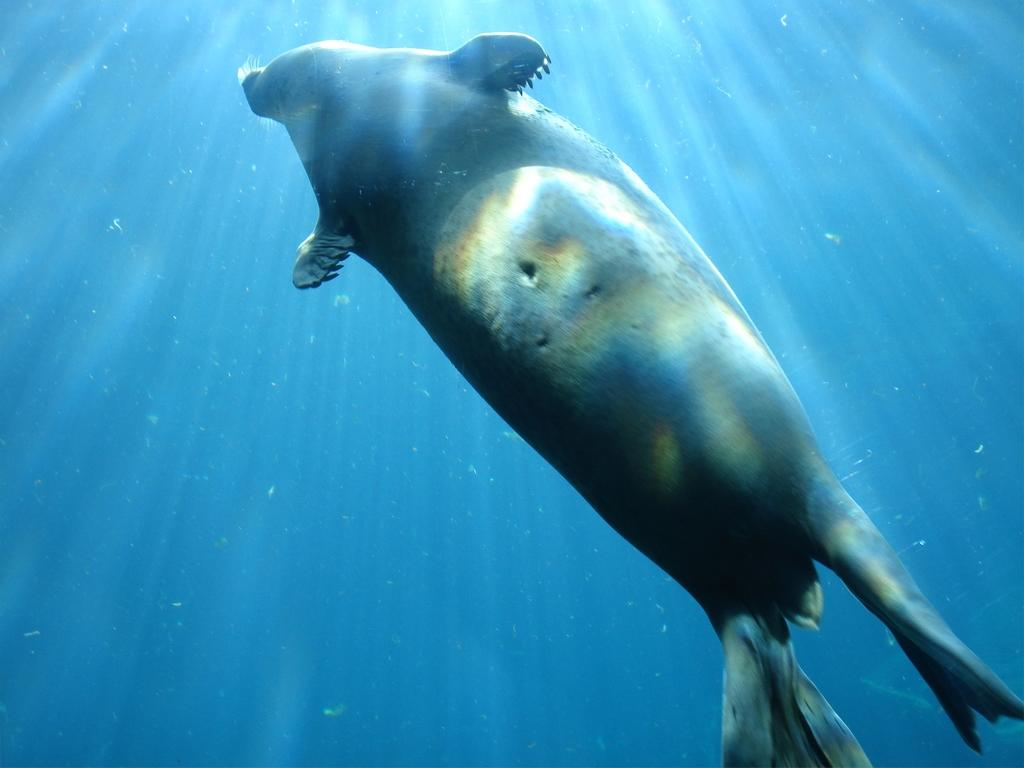What type of animals can be seen in the image? There are fish in the image. Where are the fish located? The fish are in the water. What type of butter is being used for the meal in the image? There is no meal or butter present in the image; it features fish in the water. 